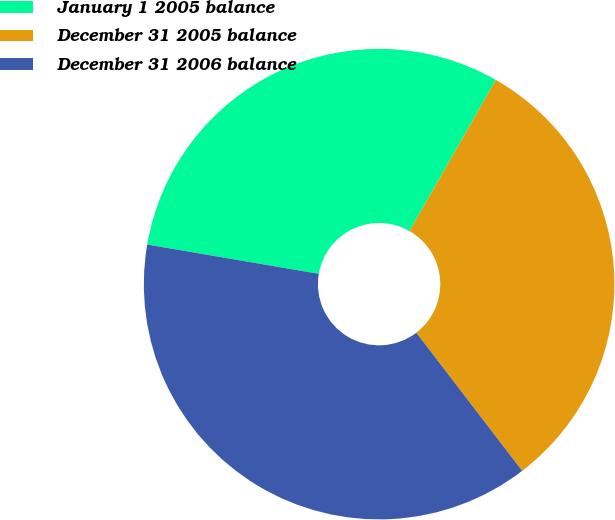<chart> <loc_0><loc_0><loc_500><loc_500><pie_chart><fcel>January 1 2005 balance<fcel>December 31 2005 balance<fcel>December 31 2006 balance<nl><fcel>30.58%<fcel>31.33%<fcel>38.1%<nl></chart> 